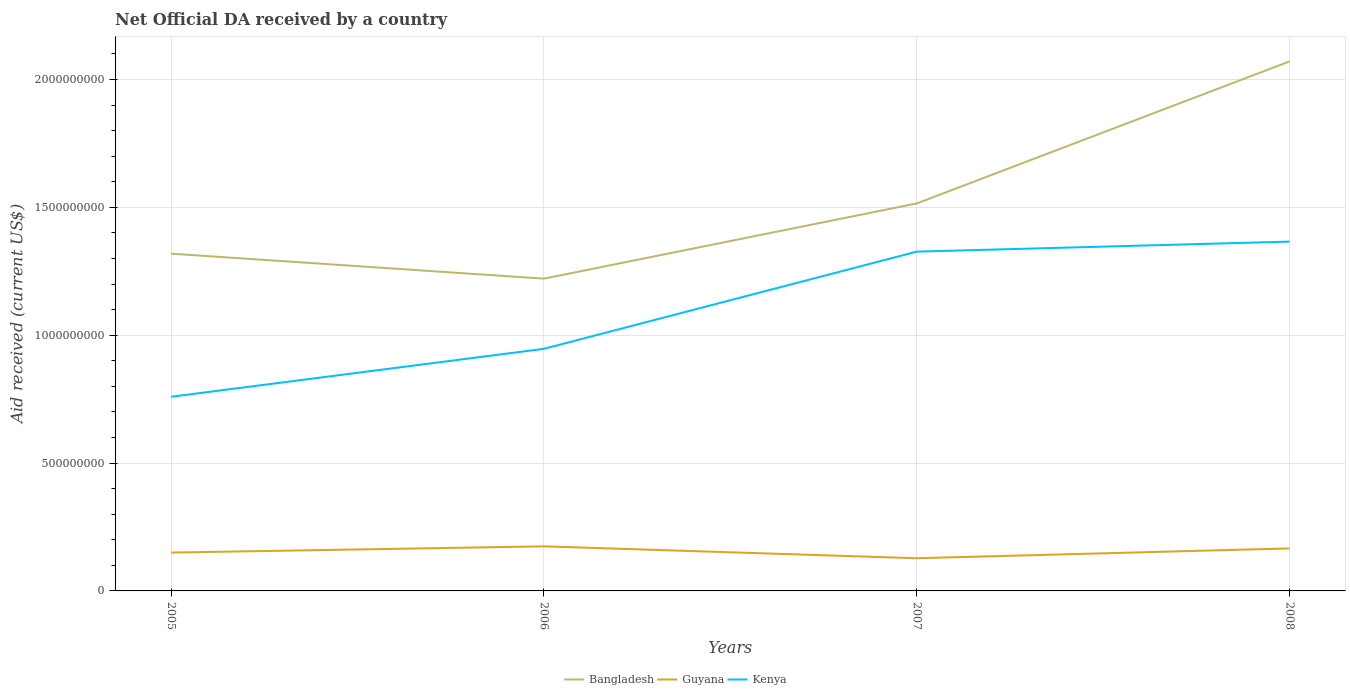How many different coloured lines are there?
Offer a very short reply. 3. Across all years, what is the maximum net official development assistance aid received in Kenya?
Your answer should be compact. 7.59e+08. What is the total net official development assistance aid received in Bangladesh in the graph?
Your answer should be compact. -5.55e+08. What is the difference between the highest and the second highest net official development assistance aid received in Kenya?
Your response must be concise. 6.07e+08. What is the difference between the highest and the lowest net official development assistance aid received in Bangladesh?
Offer a very short reply. 1. Is the net official development assistance aid received in Bangladesh strictly greater than the net official development assistance aid received in Kenya over the years?
Keep it short and to the point. No. How many lines are there?
Ensure brevity in your answer.  3. How many years are there in the graph?
Provide a succinct answer. 4. Does the graph contain any zero values?
Make the answer very short. No. Does the graph contain grids?
Provide a succinct answer. Yes. Where does the legend appear in the graph?
Offer a very short reply. Bottom center. How are the legend labels stacked?
Give a very brief answer. Horizontal. What is the title of the graph?
Ensure brevity in your answer.  Net Official DA received by a country. What is the label or title of the X-axis?
Ensure brevity in your answer.  Years. What is the label or title of the Y-axis?
Keep it short and to the point. Aid received (current US$). What is the Aid received (current US$) in Bangladesh in 2005?
Provide a short and direct response. 1.32e+09. What is the Aid received (current US$) in Guyana in 2005?
Make the answer very short. 1.50e+08. What is the Aid received (current US$) in Kenya in 2005?
Offer a very short reply. 7.59e+08. What is the Aid received (current US$) of Bangladesh in 2006?
Provide a succinct answer. 1.22e+09. What is the Aid received (current US$) in Guyana in 2006?
Your answer should be compact. 1.74e+08. What is the Aid received (current US$) of Kenya in 2006?
Your answer should be very brief. 9.47e+08. What is the Aid received (current US$) of Bangladesh in 2007?
Ensure brevity in your answer.  1.52e+09. What is the Aid received (current US$) of Guyana in 2007?
Your answer should be compact. 1.28e+08. What is the Aid received (current US$) in Kenya in 2007?
Give a very brief answer. 1.33e+09. What is the Aid received (current US$) of Bangladesh in 2008?
Your answer should be very brief. 2.07e+09. What is the Aid received (current US$) in Guyana in 2008?
Make the answer very short. 1.66e+08. What is the Aid received (current US$) in Kenya in 2008?
Provide a succinct answer. 1.37e+09. Across all years, what is the maximum Aid received (current US$) of Bangladesh?
Keep it short and to the point. 2.07e+09. Across all years, what is the maximum Aid received (current US$) of Guyana?
Give a very brief answer. 1.74e+08. Across all years, what is the maximum Aid received (current US$) of Kenya?
Ensure brevity in your answer.  1.37e+09. Across all years, what is the minimum Aid received (current US$) of Bangladesh?
Provide a succinct answer. 1.22e+09. Across all years, what is the minimum Aid received (current US$) in Guyana?
Offer a very short reply. 1.28e+08. Across all years, what is the minimum Aid received (current US$) of Kenya?
Make the answer very short. 7.59e+08. What is the total Aid received (current US$) of Bangladesh in the graph?
Offer a very short reply. 6.13e+09. What is the total Aid received (current US$) in Guyana in the graph?
Provide a short and direct response. 6.18e+08. What is the total Aid received (current US$) of Kenya in the graph?
Offer a very short reply. 4.40e+09. What is the difference between the Aid received (current US$) in Bangladesh in 2005 and that in 2006?
Make the answer very short. 9.77e+07. What is the difference between the Aid received (current US$) in Guyana in 2005 and that in 2006?
Provide a succinct answer. -2.44e+07. What is the difference between the Aid received (current US$) in Kenya in 2005 and that in 2006?
Provide a succinct answer. -1.88e+08. What is the difference between the Aid received (current US$) of Bangladesh in 2005 and that in 2007?
Ensure brevity in your answer.  -1.96e+08. What is the difference between the Aid received (current US$) of Guyana in 2005 and that in 2007?
Your response must be concise. 2.21e+07. What is the difference between the Aid received (current US$) in Kenya in 2005 and that in 2007?
Provide a succinct answer. -5.68e+08. What is the difference between the Aid received (current US$) of Bangladesh in 2005 and that in 2008?
Your answer should be very brief. -7.52e+08. What is the difference between the Aid received (current US$) in Guyana in 2005 and that in 2008?
Your answer should be compact. -1.64e+07. What is the difference between the Aid received (current US$) in Kenya in 2005 and that in 2008?
Make the answer very short. -6.07e+08. What is the difference between the Aid received (current US$) in Bangladesh in 2006 and that in 2007?
Offer a terse response. -2.94e+08. What is the difference between the Aid received (current US$) in Guyana in 2006 and that in 2007?
Provide a succinct answer. 4.65e+07. What is the difference between the Aid received (current US$) in Kenya in 2006 and that in 2007?
Provide a short and direct response. -3.80e+08. What is the difference between the Aid received (current US$) of Bangladesh in 2006 and that in 2008?
Make the answer very short. -8.49e+08. What is the difference between the Aid received (current US$) in Guyana in 2006 and that in 2008?
Offer a terse response. 8.04e+06. What is the difference between the Aid received (current US$) in Kenya in 2006 and that in 2008?
Your answer should be very brief. -4.19e+08. What is the difference between the Aid received (current US$) in Bangladesh in 2007 and that in 2008?
Provide a succinct answer. -5.55e+08. What is the difference between the Aid received (current US$) of Guyana in 2007 and that in 2008?
Offer a very short reply. -3.84e+07. What is the difference between the Aid received (current US$) of Kenya in 2007 and that in 2008?
Provide a short and direct response. -3.92e+07. What is the difference between the Aid received (current US$) of Bangladesh in 2005 and the Aid received (current US$) of Guyana in 2006?
Your response must be concise. 1.14e+09. What is the difference between the Aid received (current US$) of Bangladesh in 2005 and the Aid received (current US$) of Kenya in 2006?
Your answer should be very brief. 3.72e+08. What is the difference between the Aid received (current US$) in Guyana in 2005 and the Aid received (current US$) in Kenya in 2006?
Your answer should be compact. -7.97e+08. What is the difference between the Aid received (current US$) in Bangladesh in 2005 and the Aid received (current US$) in Guyana in 2007?
Keep it short and to the point. 1.19e+09. What is the difference between the Aid received (current US$) in Bangladesh in 2005 and the Aid received (current US$) in Kenya in 2007?
Give a very brief answer. -7.93e+06. What is the difference between the Aid received (current US$) of Guyana in 2005 and the Aid received (current US$) of Kenya in 2007?
Provide a short and direct response. -1.18e+09. What is the difference between the Aid received (current US$) of Bangladesh in 2005 and the Aid received (current US$) of Guyana in 2008?
Offer a very short reply. 1.15e+09. What is the difference between the Aid received (current US$) in Bangladesh in 2005 and the Aid received (current US$) in Kenya in 2008?
Your response must be concise. -4.71e+07. What is the difference between the Aid received (current US$) of Guyana in 2005 and the Aid received (current US$) of Kenya in 2008?
Provide a succinct answer. -1.22e+09. What is the difference between the Aid received (current US$) in Bangladesh in 2006 and the Aid received (current US$) in Guyana in 2007?
Offer a very short reply. 1.09e+09. What is the difference between the Aid received (current US$) of Bangladesh in 2006 and the Aid received (current US$) of Kenya in 2007?
Ensure brevity in your answer.  -1.06e+08. What is the difference between the Aid received (current US$) in Guyana in 2006 and the Aid received (current US$) in Kenya in 2007?
Offer a very short reply. -1.15e+09. What is the difference between the Aid received (current US$) of Bangladesh in 2006 and the Aid received (current US$) of Guyana in 2008?
Provide a succinct answer. 1.05e+09. What is the difference between the Aid received (current US$) in Bangladesh in 2006 and the Aid received (current US$) in Kenya in 2008?
Your response must be concise. -1.45e+08. What is the difference between the Aid received (current US$) of Guyana in 2006 and the Aid received (current US$) of Kenya in 2008?
Make the answer very short. -1.19e+09. What is the difference between the Aid received (current US$) of Bangladesh in 2007 and the Aid received (current US$) of Guyana in 2008?
Your response must be concise. 1.35e+09. What is the difference between the Aid received (current US$) of Bangladesh in 2007 and the Aid received (current US$) of Kenya in 2008?
Ensure brevity in your answer.  1.49e+08. What is the difference between the Aid received (current US$) of Guyana in 2007 and the Aid received (current US$) of Kenya in 2008?
Make the answer very short. -1.24e+09. What is the average Aid received (current US$) in Bangladesh per year?
Your answer should be very brief. 1.53e+09. What is the average Aid received (current US$) in Guyana per year?
Your answer should be compact. 1.55e+08. What is the average Aid received (current US$) in Kenya per year?
Provide a succinct answer. 1.10e+09. In the year 2005, what is the difference between the Aid received (current US$) of Bangladesh and Aid received (current US$) of Guyana?
Provide a short and direct response. 1.17e+09. In the year 2005, what is the difference between the Aid received (current US$) in Bangladesh and Aid received (current US$) in Kenya?
Make the answer very short. 5.60e+08. In the year 2005, what is the difference between the Aid received (current US$) in Guyana and Aid received (current US$) in Kenya?
Ensure brevity in your answer.  -6.09e+08. In the year 2006, what is the difference between the Aid received (current US$) of Bangladesh and Aid received (current US$) of Guyana?
Your answer should be very brief. 1.05e+09. In the year 2006, what is the difference between the Aid received (current US$) of Bangladesh and Aid received (current US$) of Kenya?
Your answer should be compact. 2.74e+08. In the year 2006, what is the difference between the Aid received (current US$) of Guyana and Aid received (current US$) of Kenya?
Keep it short and to the point. -7.72e+08. In the year 2007, what is the difference between the Aid received (current US$) in Bangladesh and Aid received (current US$) in Guyana?
Make the answer very short. 1.39e+09. In the year 2007, what is the difference between the Aid received (current US$) in Bangladesh and Aid received (current US$) in Kenya?
Ensure brevity in your answer.  1.88e+08. In the year 2007, what is the difference between the Aid received (current US$) of Guyana and Aid received (current US$) of Kenya?
Offer a terse response. -1.20e+09. In the year 2008, what is the difference between the Aid received (current US$) of Bangladesh and Aid received (current US$) of Guyana?
Offer a terse response. 1.90e+09. In the year 2008, what is the difference between the Aid received (current US$) in Bangladesh and Aid received (current US$) in Kenya?
Offer a terse response. 7.05e+08. In the year 2008, what is the difference between the Aid received (current US$) of Guyana and Aid received (current US$) of Kenya?
Offer a terse response. -1.20e+09. What is the ratio of the Aid received (current US$) of Bangladesh in 2005 to that in 2006?
Make the answer very short. 1.08. What is the ratio of the Aid received (current US$) of Guyana in 2005 to that in 2006?
Offer a very short reply. 0.86. What is the ratio of the Aid received (current US$) in Kenya in 2005 to that in 2006?
Your response must be concise. 0.8. What is the ratio of the Aid received (current US$) in Bangladesh in 2005 to that in 2007?
Ensure brevity in your answer.  0.87. What is the ratio of the Aid received (current US$) in Guyana in 2005 to that in 2007?
Make the answer very short. 1.17. What is the ratio of the Aid received (current US$) in Kenya in 2005 to that in 2007?
Offer a very short reply. 0.57. What is the ratio of the Aid received (current US$) in Bangladesh in 2005 to that in 2008?
Offer a very short reply. 0.64. What is the ratio of the Aid received (current US$) in Guyana in 2005 to that in 2008?
Provide a succinct answer. 0.9. What is the ratio of the Aid received (current US$) in Kenya in 2005 to that in 2008?
Keep it short and to the point. 0.56. What is the ratio of the Aid received (current US$) of Bangladesh in 2006 to that in 2007?
Provide a succinct answer. 0.81. What is the ratio of the Aid received (current US$) in Guyana in 2006 to that in 2007?
Keep it short and to the point. 1.36. What is the ratio of the Aid received (current US$) of Kenya in 2006 to that in 2007?
Make the answer very short. 0.71. What is the ratio of the Aid received (current US$) in Bangladesh in 2006 to that in 2008?
Your answer should be very brief. 0.59. What is the ratio of the Aid received (current US$) of Guyana in 2006 to that in 2008?
Offer a terse response. 1.05. What is the ratio of the Aid received (current US$) in Kenya in 2006 to that in 2008?
Your answer should be compact. 0.69. What is the ratio of the Aid received (current US$) in Bangladesh in 2007 to that in 2008?
Give a very brief answer. 0.73. What is the ratio of the Aid received (current US$) in Guyana in 2007 to that in 2008?
Provide a succinct answer. 0.77. What is the ratio of the Aid received (current US$) in Kenya in 2007 to that in 2008?
Ensure brevity in your answer.  0.97. What is the difference between the highest and the second highest Aid received (current US$) of Bangladesh?
Keep it short and to the point. 5.55e+08. What is the difference between the highest and the second highest Aid received (current US$) of Guyana?
Provide a short and direct response. 8.04e+06. What is the difference between the highest and the second highest Aid received (current US$) of Kenya?
Your response must be concise. 3.92e+07. What is the difference between the highest and the lowest Aid received (current US$) in Bangladesh?
Make the answer very short. 8.49e+08. What is the difference between the highest and the lowest Aid received (current US$) in Guyana?
Your response must be concise. 4.65e+07. What is the difference between the highest and the lowest Aid received (current US$) in Kenya?
Your answer should be compact. 6.07e+08. 